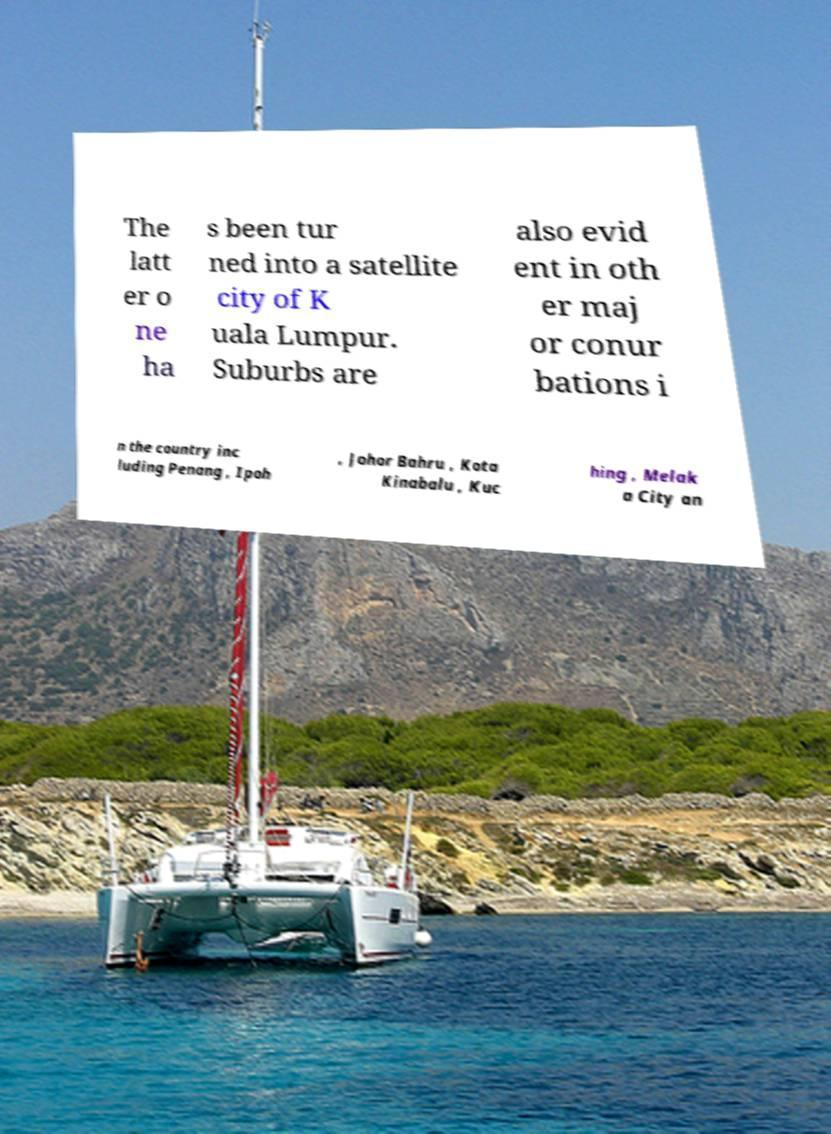Please read and relay the text visible in this image. What does it say? The latt er o ne ha s been tur ned into a satellite city of K uala Lumpur. Suburbs are also evid ent in oth er maj or conur bations i n the country inc luding Penang , Ipoh , Johor Bahru , Kota Kinabalu , Kuc hing , Melak a City an 